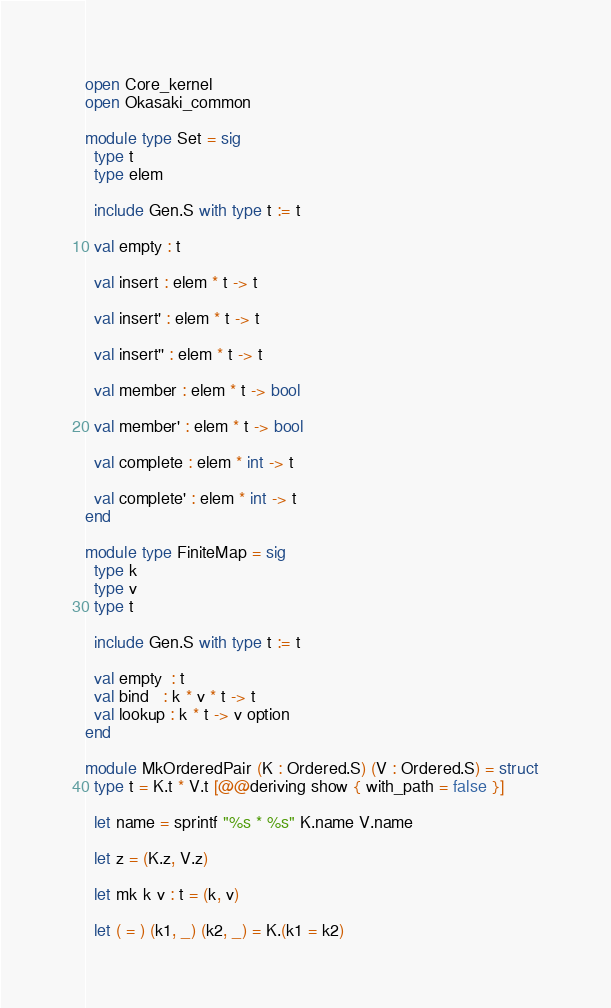Convert code to text. <code><loc_0><loc_0><loc_500><loc_500><_OCaml_>open Core_kernel
open Okasaki_common

module type Set = sig
  type t
  type elem

  include Gen.S with type t := t

  val empty : t

  val insert : elem * t -> t

  val insert' : elem * t -> t

  val insert'' : elem * t -> t

  val member : elem * t -> bool

  val member' : elem * t -> bool

  val complete : elem * int -> t

  val complete' : elem * int -> t
end

module type FiniteMap = sig
  type k
  type v
  type t

  include Gen.S with type t := t

  val empty  : t
  val bind   : k * v * t -> t
  val lookup : k * t -> v option
end

module MkOrderedPair (K : Ordered.S) (V : Ordered.S) = struct
  type t = K.t * V.t [@@deriving show { with_path = false }]

  let name = sprintf "%s * %s" K.name V.name

  let z = (K.z, V.z)

  let mk k v : t = (k, v)

  let ( = ) (k1, _) (k2, _) = K.(k1 = k2)</code> 